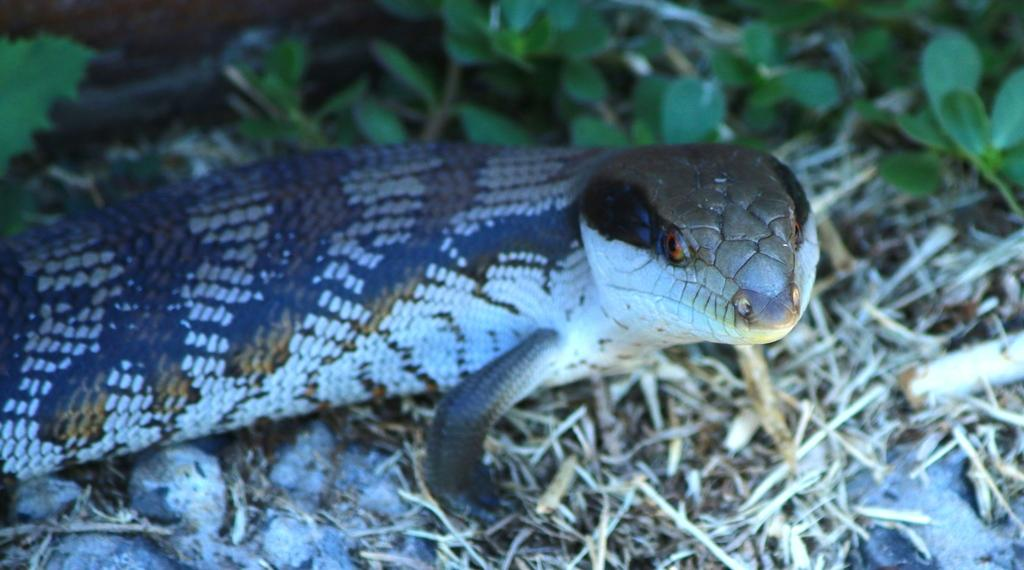What type of animal is in the image? There is a reptile in the image. What objects can be seen in the image besides the reptile? There are sticks and leaves on the ground visible in the image. How would you describe the lighting in the image? The background of the image is dark. What news story is being discussed by the man in the image? There is no man present in the image, and therefore no news story can be discussed. What type of canvas is being used to paint the reptile in the image? There is no canvas or painting activity present in the image; it is a photograph of a reptile in its natural environment. 